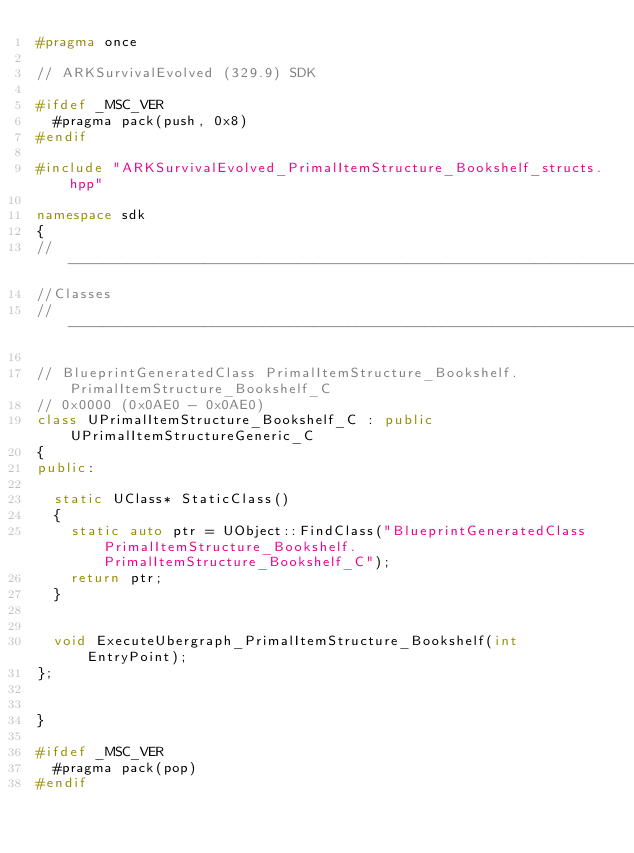Convert code to text. <code><loc_0><loc_0><loc_500><loc_500><_C++_>#pragma once

// ARKSurvivalEvolved (329.9) SDK

#ifdef _MSC_VER
	#pragma pack(push, 0x8)
#endif

#include "ARKSurvivalEvolved_PrimalItemStructure_Bookshelf_structs.hpp"

namespace sdk
{
//---------------------------------------------------------------------------
//Classes
//---------------------------------------------------------------------------

// BlueprintGeneratedClass PrimalItemStructure_Bookshelf.PrimalItemStructure_Bookshelf_C
// 0x0000 (0x0AE0 - 0x0AE0)
class UPrimalItemStructure_Bookshelf_C : public UPrimalItemStructureGeneric_C
{
public:

	static UClass* StaticClass()
	{
		static auto ptr = UObject::FindClass("BlueprintGeneratedClass PrimalItemStructure_Bookshelf.PrimalItemStructure_Bookshelf_C");
		return ptr;
	}


	void ExecuteUbergraph_PrimalItemStructure_Bookshelf(int EntryPoint);
};


}

#ifdef _MSC_VER
	#pragma pack(pop)
#endif
</code> 